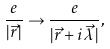<formula> <loc_0><loc_0><loc_500><loc_500>\frac { e } { | \vec { r } \, | } \rightarrow \frac { e } { | \vec { r } + i \vec { \lambda } \, | } ,</formula> 